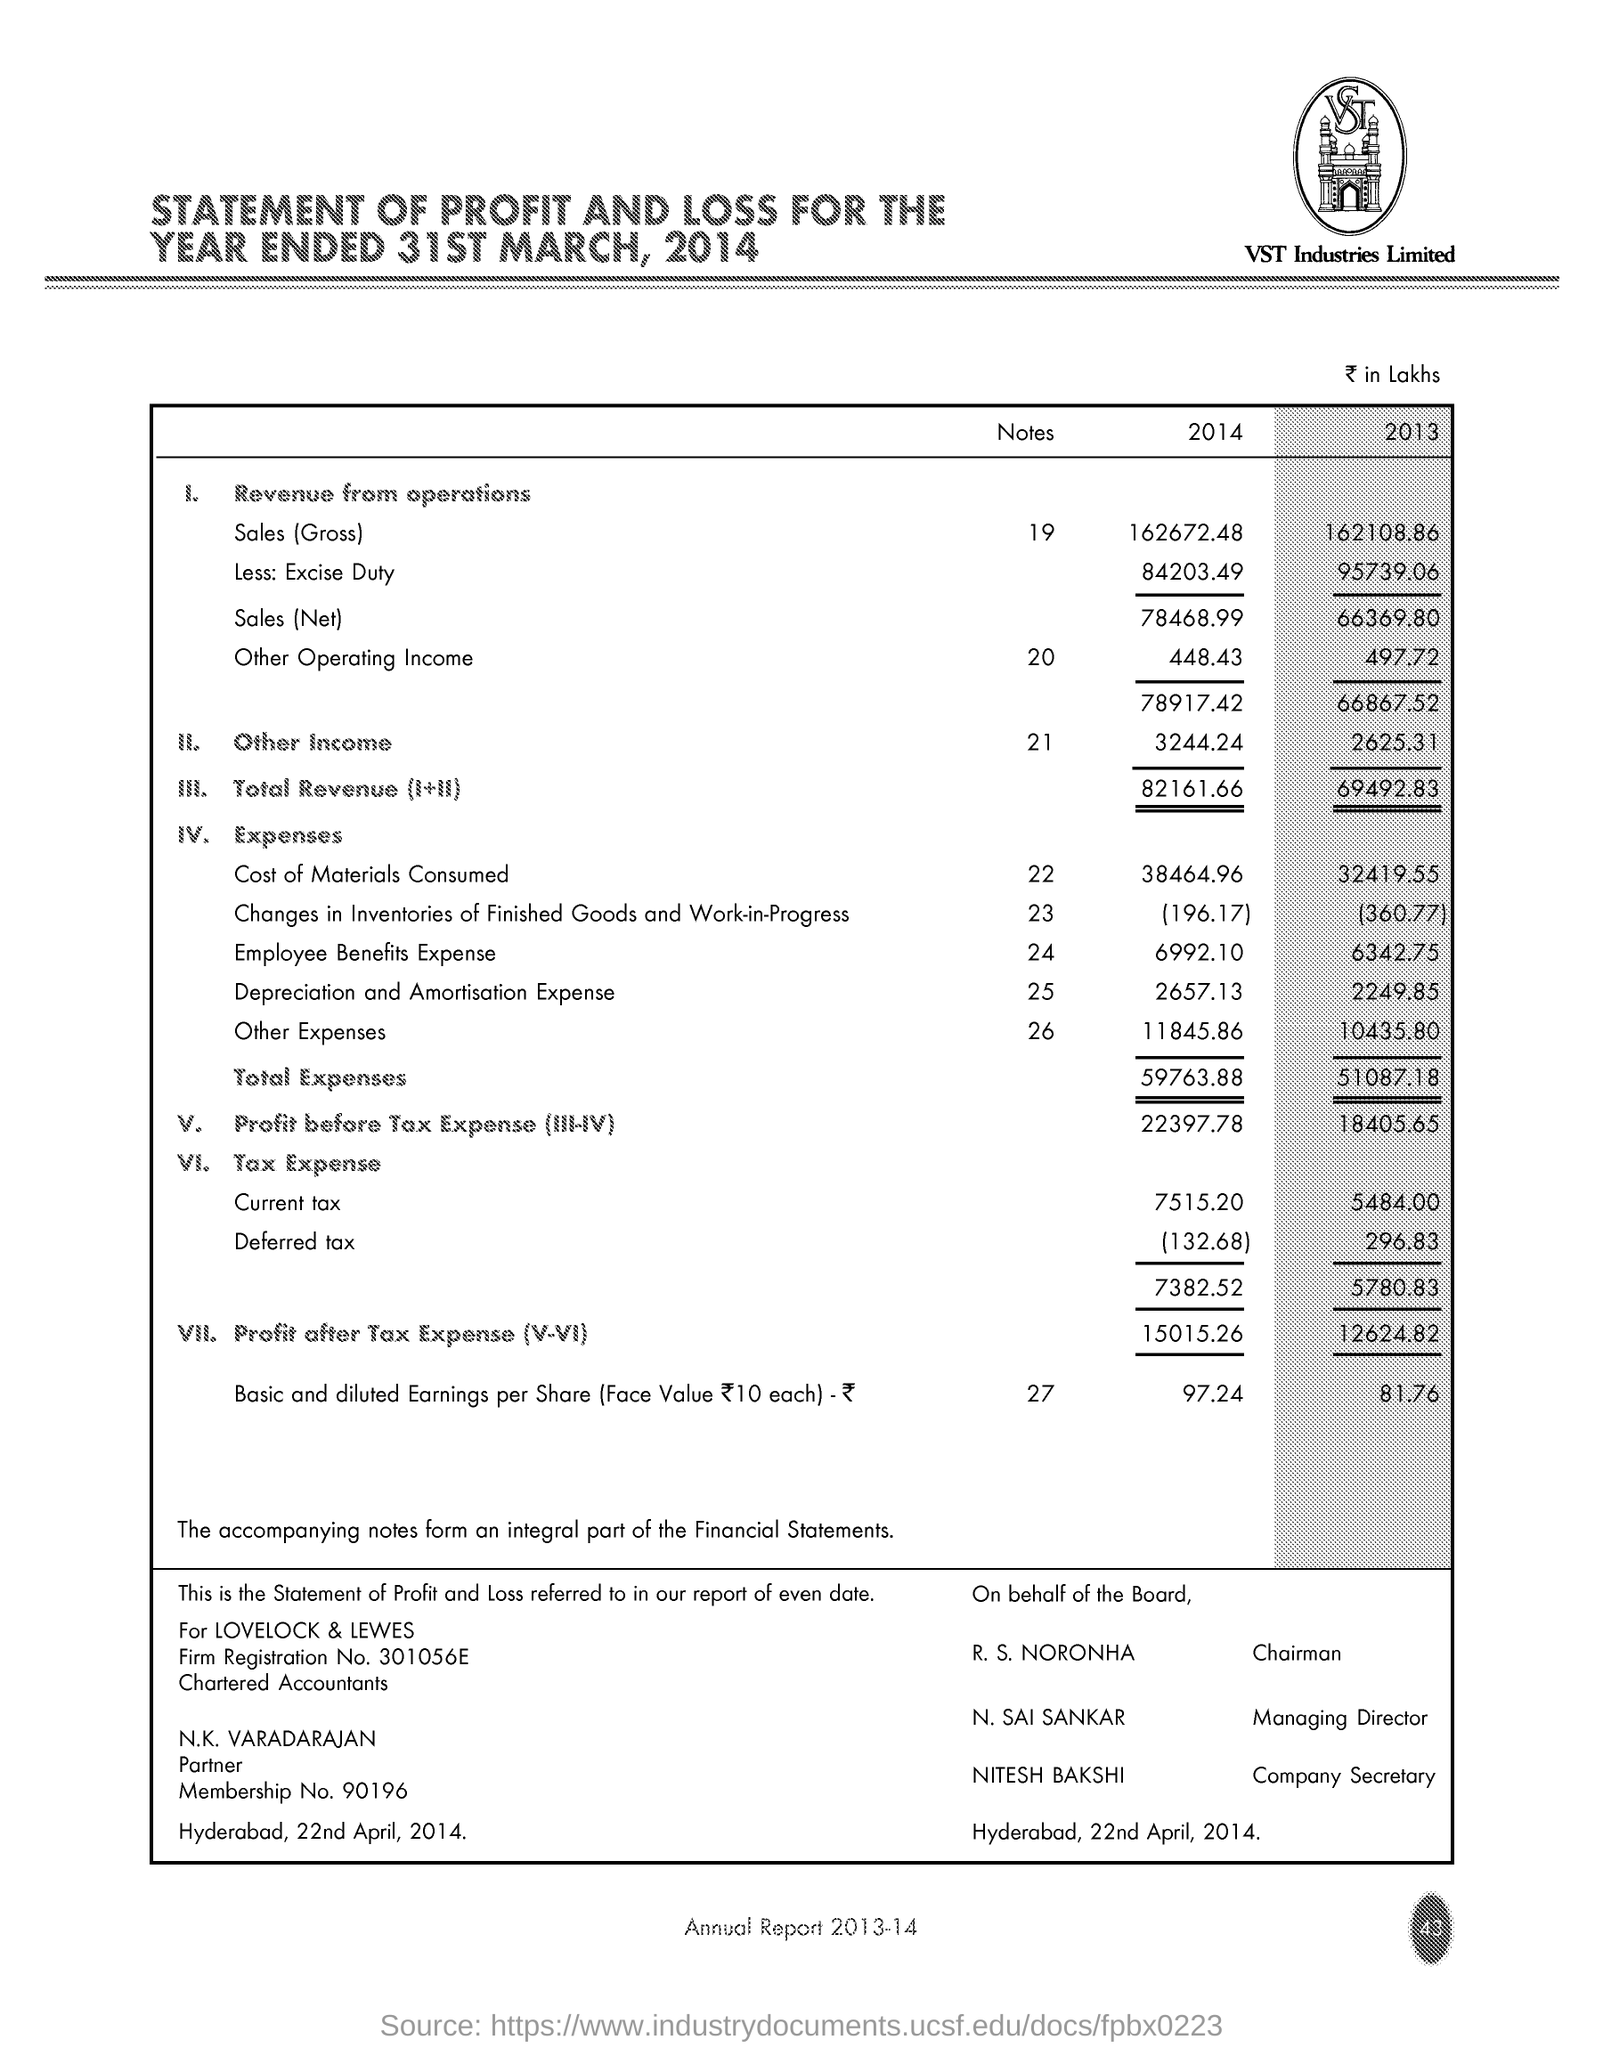What is the 'total Revenue' for the year 2014 ?
Offer a terse response. 82161.66. How much is the 'cost of materials consumed' for the year 2013 ?
Ensure brevity in your answer.  32419.55. Who is the managing director ?
Offer a very short reply. N. SAI SANKAR. 